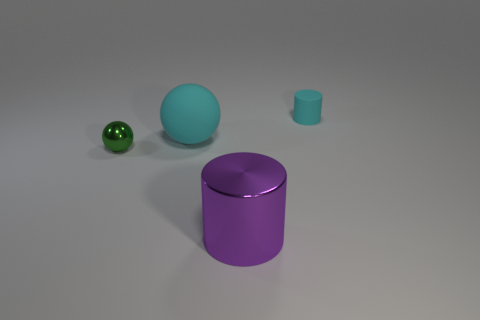Does the matte cylinder have the same color as the big matte object?
Make the answer very short. Yes. What is the shape of the tiny object that is on the left side of the cyan matte thing in front of the cyan thing that is right of the purple metallic thing?
Make the answer very short. Sphere. How many big metallic cylinders are to the left of the tiny rubber cylinder?
Ensure brevity in your answer.  1. Is the big object that is behind the tiny green ball made of the same material as the small cyan thing?
Provide a succinct answer. Yes. How many other objects are there of the same shape as the large purple metal object?
Your answer should be very brief. 1. What number of cyan things are to the left of the rubber thing behind the ball behind the green ball?
Give a very brief answer. 1. The cylinder behind the large purple metal object is what color?
Offer a terse response. Cyan. There is a cylinder that is on the right side of the purple thing; does it have the same color as the big ball?
Ensure brevity in your answer.  Yes. What size is the cyan thing that is the same shape as the tiny green metallic thing?
Ensure brevity in your answer.  Large. There is a cylinder that is to the right of the big object that is in front of the matte thing that is in front of the small cylinder; what is it made of?
Keep it short and to the point. Rubber. 